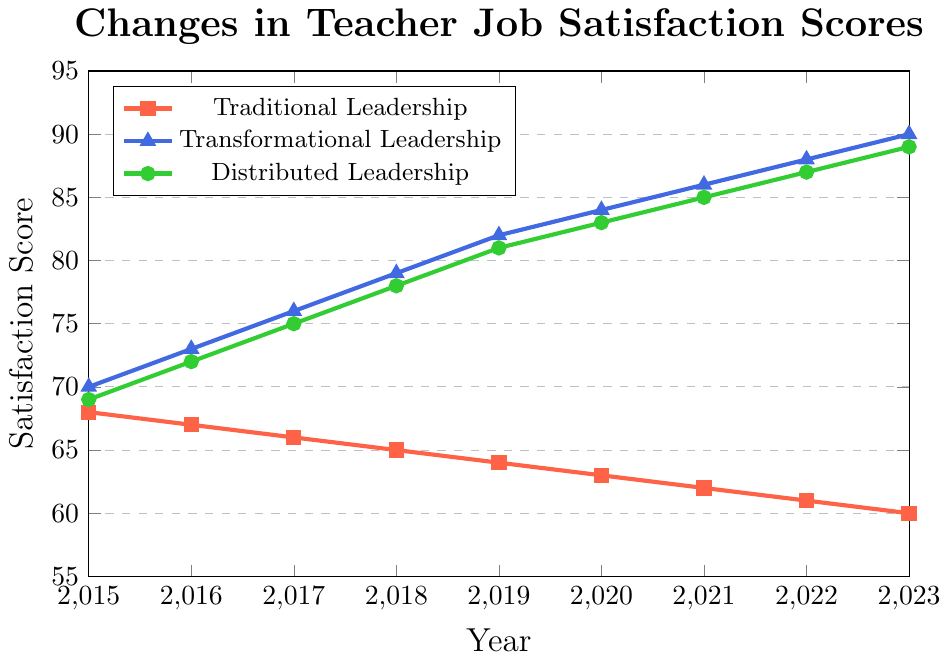What trend is observed in the job satisfaction scores for Traditional Leadership from 2015 to 2023? The job satisfaction scores for Traditional Leadership consistently decrease from 68 in 2015 to 60 in 2023.
Answer: Decreasing Which type of leadership shows the highest job satisfaction score in the year 2021? For the year 2021, the job satisfaction scores are 62 for Traditional Leadership, 86 for Transformational Leadership, and 85 for Distributed Leadership. So, Transformational Leadership shows the highest score.
Answer: Transformational Leadership How much did the job satisfaction score increase for Transformational Leadership from 2016 to 2018? The job satisfaction score for Transformational Leadership was 73 in 2016 and 79 in 2018. The increase is 79 - 73 = 6.
Answer: 6 Between which two consecutive years did Distributed Leadership experience the largest increase in job satisfaction scores? The increases between consecutive years are: 
72 to 75 (3) between 2016 and 2017, 
75 to 78 (3) between 2017 and 2018, 
78 to 81 (3) between 2018 and 2019, 
81 to 83 (2) between 2019 and 2020, 
83 to 85 (2) between 2020 and 2021, 
85 to 87 (2) between 2021 and 2022, 
87 to 89 (2) between 2022 and 2023. 
From this, the largest increase occurred between 2016 and 2017, 2017 and 2018, and 2018 and 2019, all with 3 points increase.
Answer: 2016-2017, 2017-2018, 2018-2019 What is the difference in job satisfaction scores between Traditional and Distributed Leadership in 2020? In 2020, the job satisfaction scores are 63 for Traditional Leadership and 83 for Distributed Leadership. The difference is 83 - 63 = 20.
Answer: 20 Compare the trends in job satisfaction scores for Transformational and Distributed Leadership from 2015 to 2023. From 2015 to 2023, both Transformational and Distributed Leadership show an increasing trend in job satisfaction scores. Transformational Leadership scores increased from 70 to 90, and Distributed Leadership scores increased from 69 to 89. Both trends are consistently upward.
Answer: Increasing for both Which leadership style consistently had the lowest job satisfaction scores from 2015 to 2023? Traditional Leadership had the lowest job satisfaction scores consistently from 2015 to 2023 when compared to Transformational and Distributed Leadership.
Answer: Traditional Leadership By how much did the job satisfaction score for Distributed Leadership change from 2015 to 2023? The job satisfaction score for Distributed Leadership was 69 in 2015 and 89 in 2023. The change is 89 - 69 = 20.
Answer: 20 